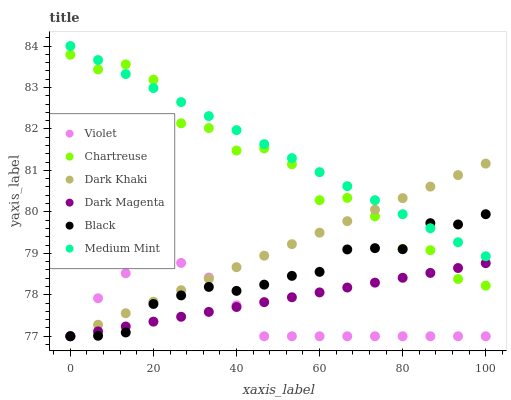Does Violet have the minimum area under the curve?
Answer yes or no. Yes. Does Medium Mint have the maximum area under the curve?
Answer yes or no. Yes. Does Dark Magenta have the minimum area under the curve?
Answer yes or no. No. Does Dark Magenta have the maximum area under the curve?
Answer yes or no. No. Is Dark Khaki the smoothest?
Answer yes or no. Yes. Is Chartreuse the roughest?
Answer yes or no. Yes. Is Dark Magenta the smoothest?
Answer yes or no. No. Is Dark Magenta the roughest?
Answer yes or no. No. Does Dark Magenta have the lowest value?
Answer yes or no. Yes. Does Chartreuse have the lowest value?
Answer yes or no. No. Does Medium Mint have the highest value?
Answer yes or no. Yes. Does Dark Khaki have the highest value?
Answer yes or no. No. Is Dark Magenta less than Medium Mint?
Answer yes or no. Yes. Is Medium Mint greater than Dark Magenta?
Answer yes or no. Yes. Does Dark Khaki intersect Medium Mint?
Answer yes or no. Yes. Is Dark Khaki less than Medium Mint?
Answer yes or no. No. Is Dark Khaki greater than Medium Mint?
Answer yes or no. No. Does Dark Magenta intersect Medium Mint?
Answer yes or no. No. 